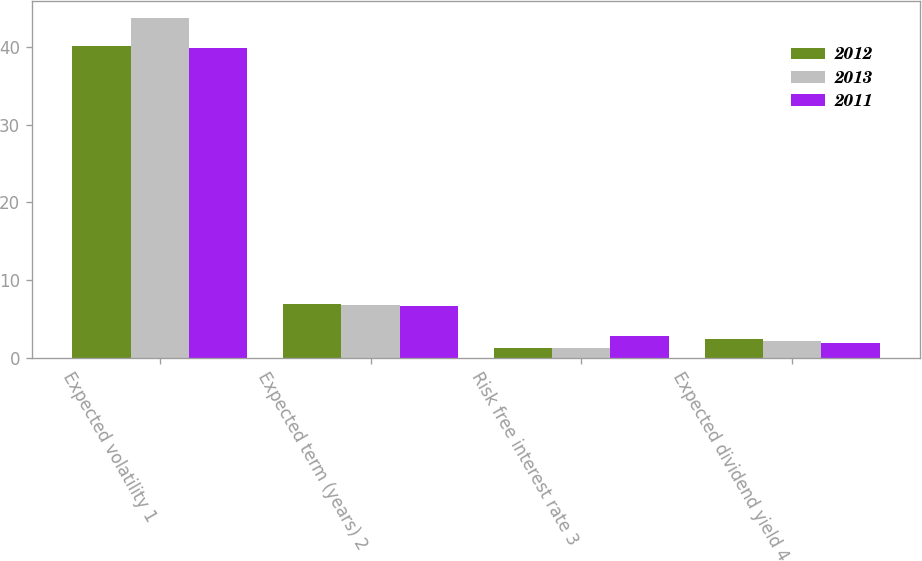Convert chart. <chart><loc_0><loc_0><loc_500><loc_500><stacked_bar_chart><ecel><fcel>Expected volatility 1<fcel>Expected term (years) 2<fcel>Risk free interest rate 3<fcel>Expected dividend yield 4<nl><fcel>2012<fcel>40.2<fcel>6.9<fcel>1.3<fcel>2.4<nl><fcel>2013<fcel>43.8<fcel>6.8<fcel>1.3<fcel>2.1<nl><fcel>2011<fcel>39.9<fcel>6.7<fcel>2.8<fcel>1.9<nl></chart> 